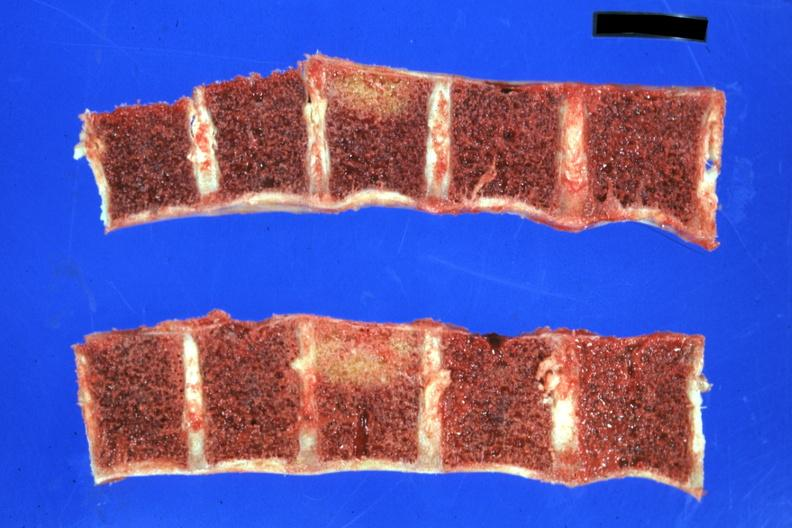does this image show lesions well shown?
Answer the question using a single word or phrase. Yes 